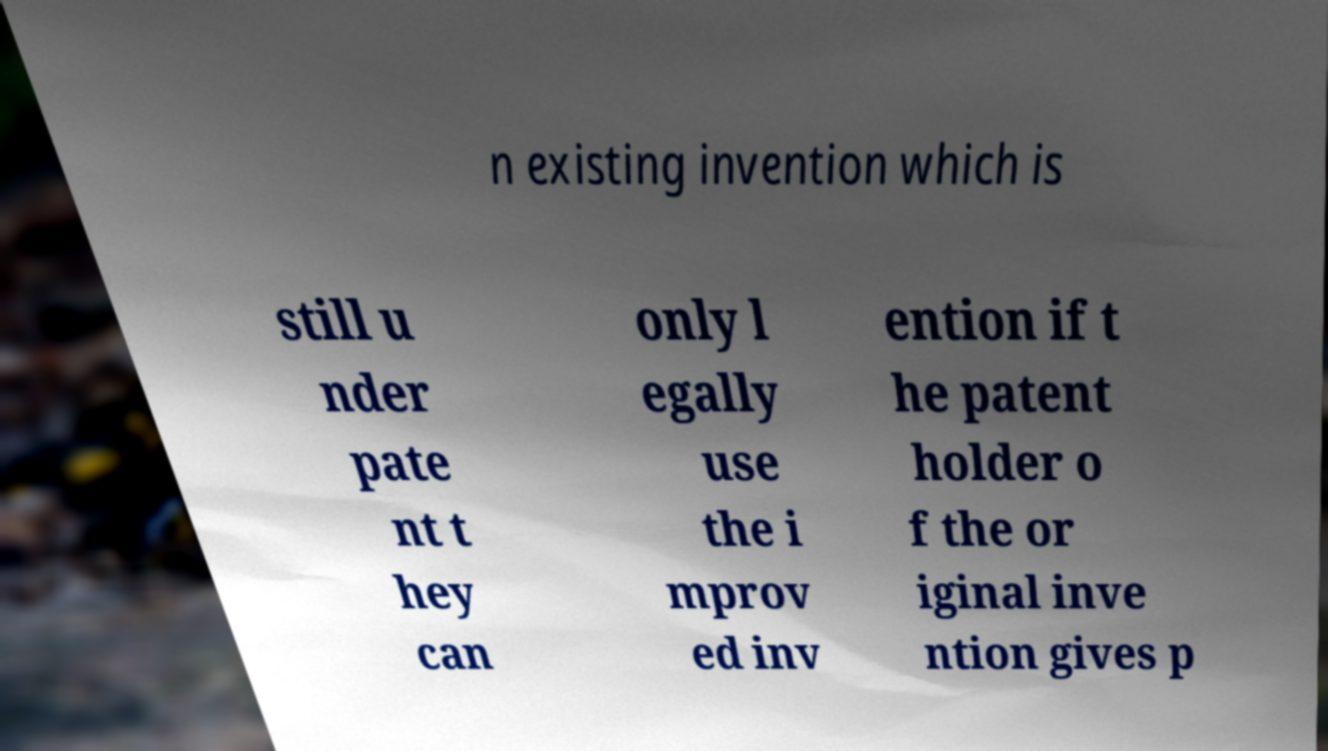Could you assist in decoding the text presented in this image and type it out clearly? n existing invention which is still u nder pate nt t hey can only l egally use the i mprov ed inv ention if t he patent holder o f the or iginal inve ntion gives p 